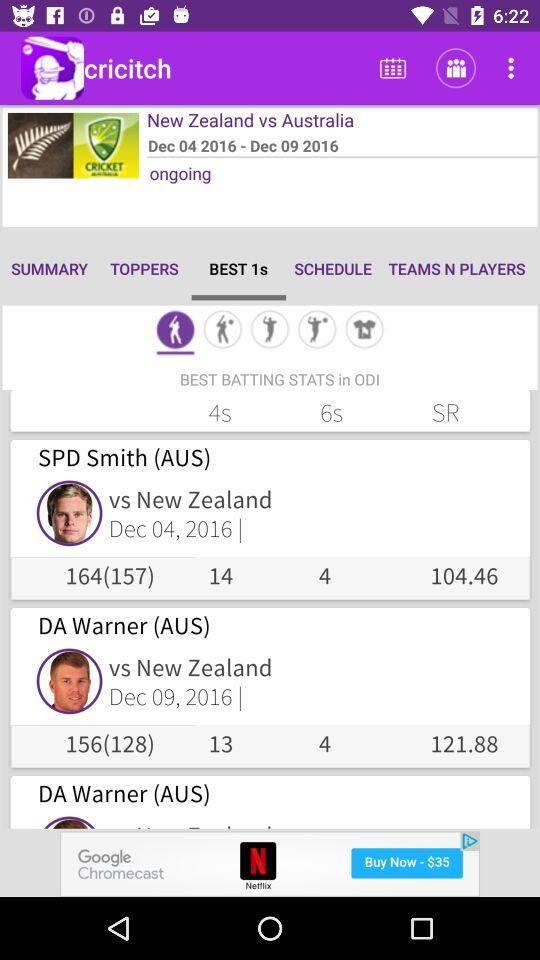How many players have a score of more than 100?
Answer the question using a single word or phrase. 2 